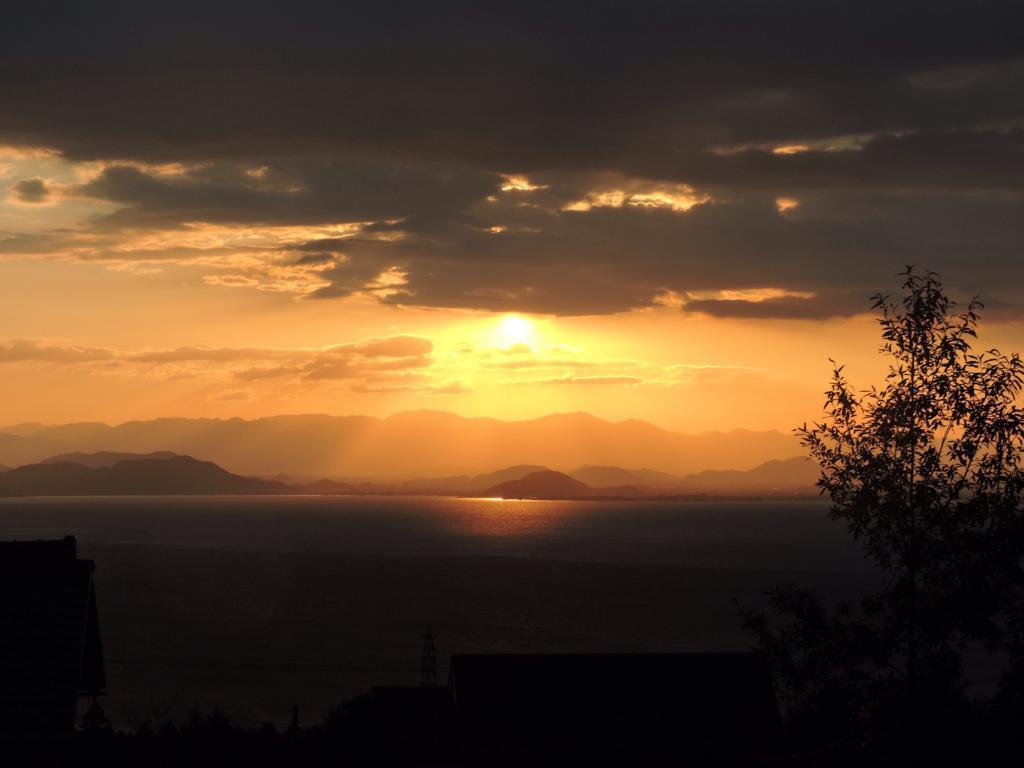What type of vegetation is present at the bottom of the image? There are trees at the bottom of the image. What natural feature is also present at the bottom of the image? There is water at the bottom of the image. What geographical feature can be seen in the middle of the image? There are hills in the middle of the image. What is visible in the top part of the image? The sky is visible in the image. What celestial body can be seen in the sky? The sun is present in the image. What atmospheric phenomenon is also visible in the sky? There are clouds in the image. What type of transport is used by the brother during his journey in the image? There is no brother or journey present in the image. What mode of transport is used to travel to the destination in the image? There is no transport or destination present in the image. 